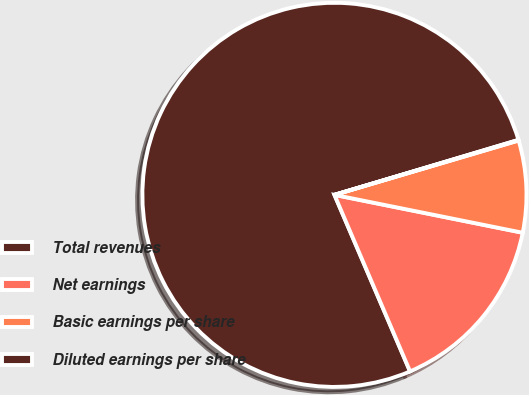<chart> <loc_0><loc_0><loc_500><loc_500><pie_chart><fcel>Total revenues<fcel>Net earnings<fcel>Basic earnings per share<fcel>Diluted earnings per share<nl><fcel>76.82%<fcel>15.4%<fcel>7.73%<fcel>0.05%<nl></chart> 